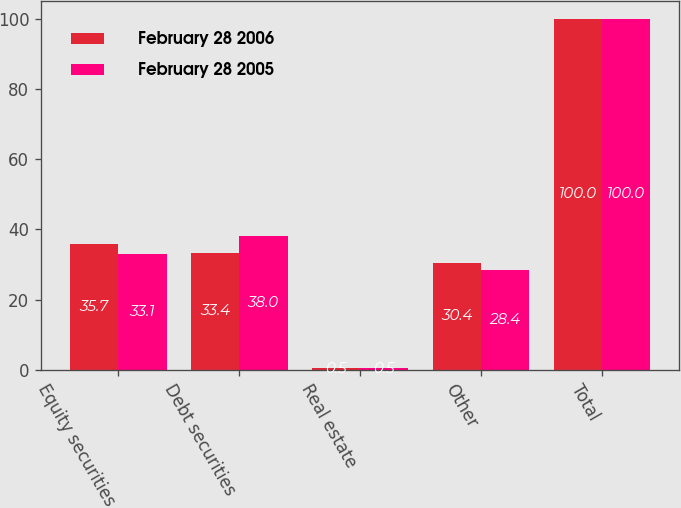<chart> <loc_0><loc_0><loc_500><loc_500><stacked_bar_chart><ecel><fcel>Equity securities<fcel>Debt securities<fcel>Real estate<fcel>Other<fcel>Total<nl><fcel>February 28 2006<fcel>35.7<fcel>33.4<fcel>0.5<fcel>30.4<fcel>100<nl><fcel>February 28 2005<fcel>33.1<fcel>38<fcel>0.5<fcel>28.4<fcel>100<nl></chart> 